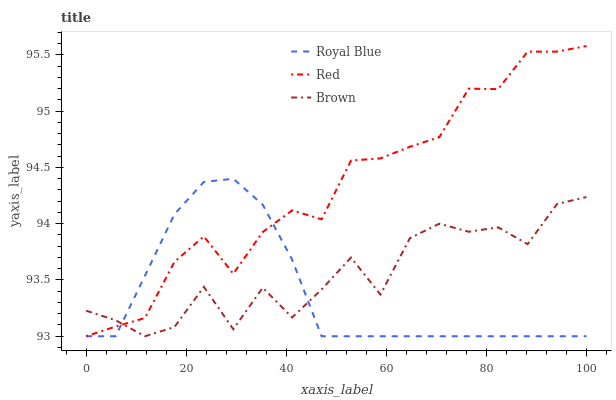Does Royal Blue have the minimum area under the curve?
Answer yes or no. Yes. Does Red have the maximum area under the curve?
Answer yes or no. Yes. Does Brown have the minimum area under the curve?
Answer yes or no. No. Does Brown have the maximum area under the curve?
Answer yes or no. No. Is Royal Blue the smoothest?
Answer yes or no. Yes. Is Brown the roughest?
Answer yes or no. Yes. Is Red the smoothest?
Answer yes or no. No. Is Red the roughest?
Answer yes or no. No. Does Royal Blue have the lowest value?
Answer yes or no. Yes. Does Red have the highest value?
Answer yes or no. Yes. Does Brown have the highest value?
Answer yes or no. No. Does Red intersect Brown?
Answer yes or no. Yes. Is Red less than Brown?
Answer yes or no. No. Is Red greater than Brown?
Answer yes or no. No. 